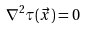Convert formula to latex. <formula><loc_0><loc_0><loc_500><loc_500>\nabla ^ { 2 } \tau ( \vec { x } ) = 0</formula> 